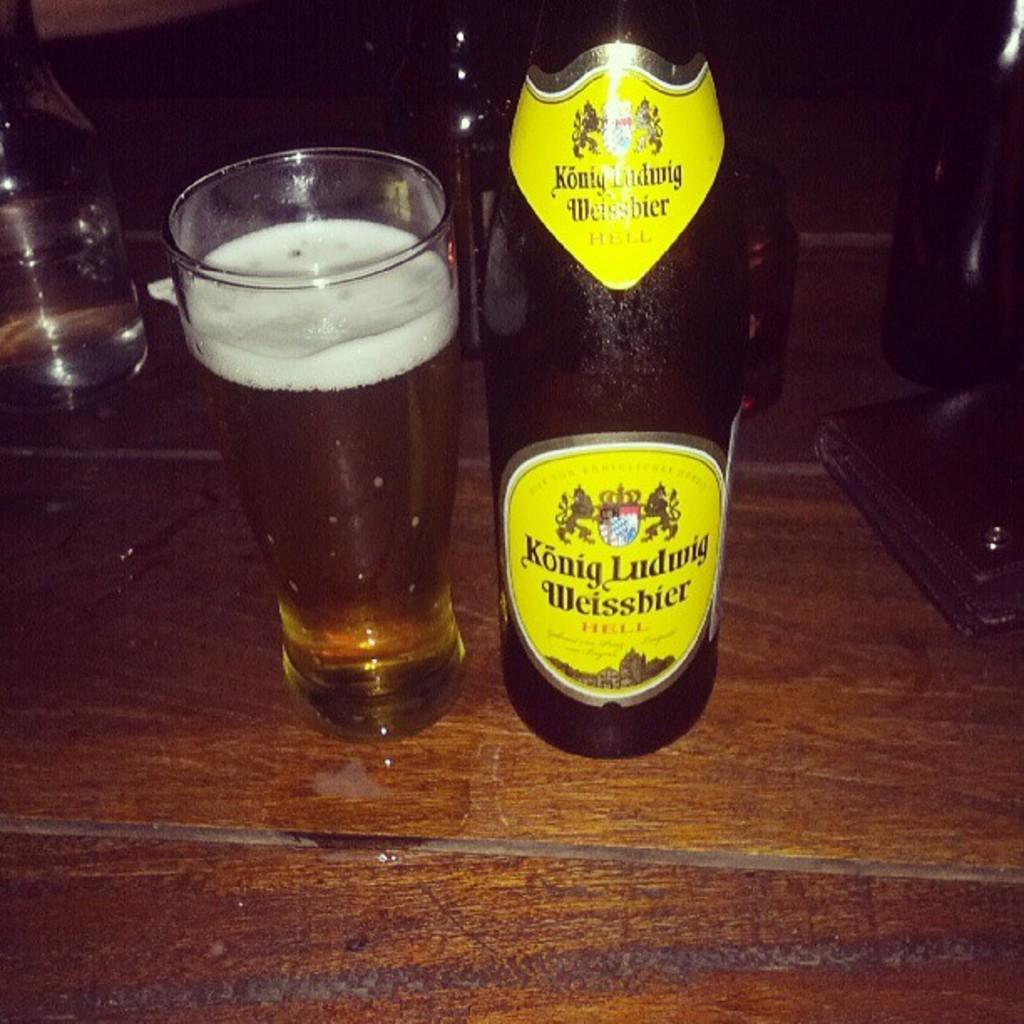<image>
Render a clear and concise summary of the photo. A bottle of Konig Ludwig Weissbier sits next to a full pint glass on a wooden countertop. 